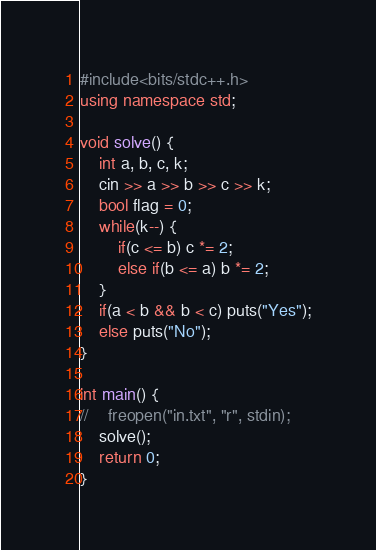<code> <loc_0><loc_0><loc_500><loc_500><_C++_>#include<bits/stdc++.h>
using namespace std;

void solve() {
    int a, b, c, k;
    cin >> a >> b >> c >> k;
    bool flag = 0;
    while(k--) {
        if(c <= b) c *= 2;
        else if(b <= a) b *= 2;
    }
    if(a < b && b < c) puts("Yes");
    else puts("No");
}

int main() {
//    freopen("in.txt", "r", stdin);
    solve();
    return 0;
}
</code> 